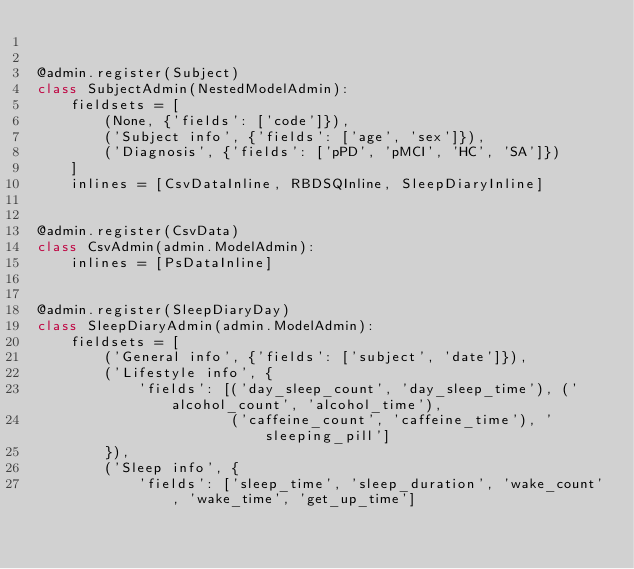<code> <loc_0><loc_0><loc_500><loc_500><_Python_>

@admin.register(Subject)
class SubjectAdmin(NestedModelAdmin):
    fieldsets = [
        (None, {'fields': ['code']}),
        ('Subject info', {'fields': ['age', 'sex']}),
        ('Diagnosis', {'fields': ['pPD', 'pMCI', 'HC', 'SA']})
    ]
    inlines = [CsvDataInline, RBDSQInline, SleepDiaryInline]


@admin.register(CsvData)
class CsvAdmin(admin.ModelAdmin):
    inlines = [PsDataInline]


@admin.register(SleepDiaryDay)
class SleepDiaryAdmin(admin.ModelAdmin):
    fieldsets = [
        ('General info', {'fields': ['subject', 'date']}),
        ('Lifestyle info', {
            'fields': [('day_sleep_count', 'day_sleep_time'), ('alcohol_count', 'alcohol_time'),
                       ('caffeine_count', 'caffeine_time'), 'sleeping_pill']
        }),
        ('Sleep info', {
            'fields': ['sleep_time', 'sleep_duration', 'wake_count', 'wake_time', 'get_up_time']</code> 